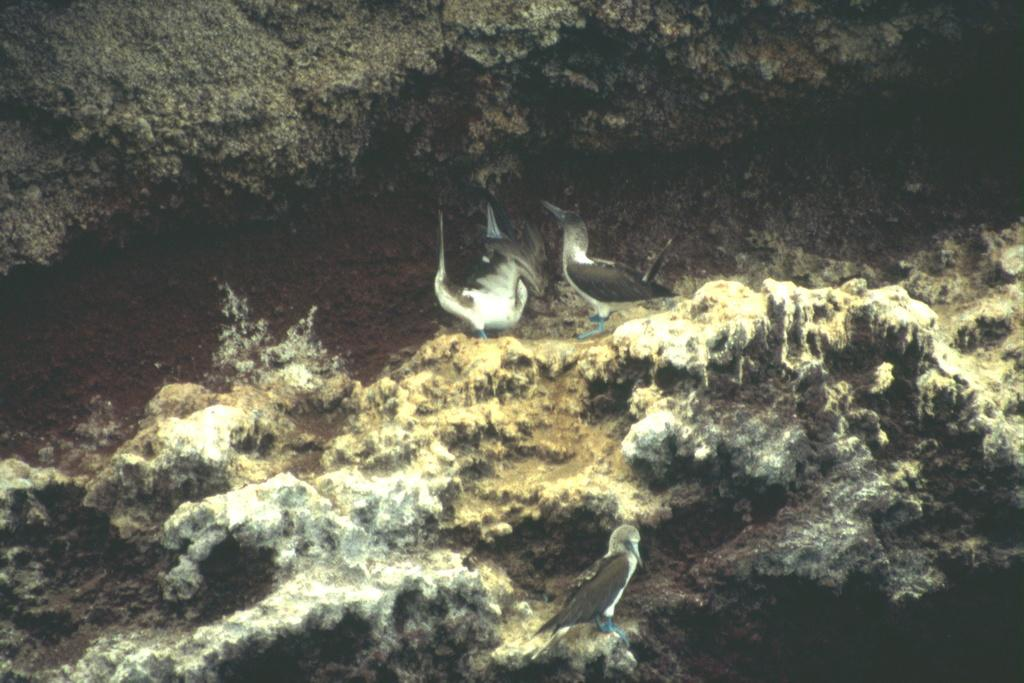What is located in the center of the image? There are birds in the center of the image. What can be seen in the background of the image? There are rocks in the background of the image. What type of reward can be seen being given to the birds in the image? There is no reward being given to the birds in the image; it only features birds and rocks. 